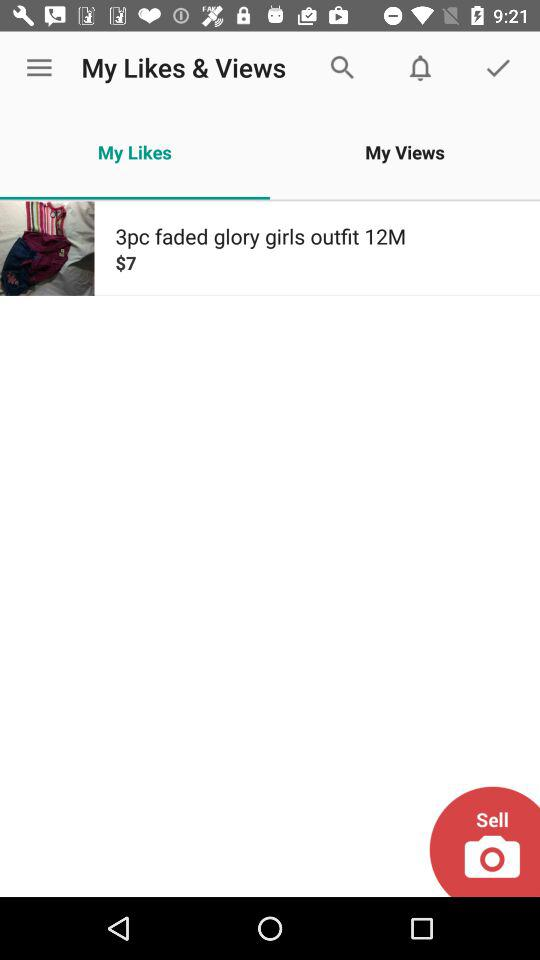Who is the size of the outfit suitable for? The size of the outfit is suitable for a 12-month-old baby. 